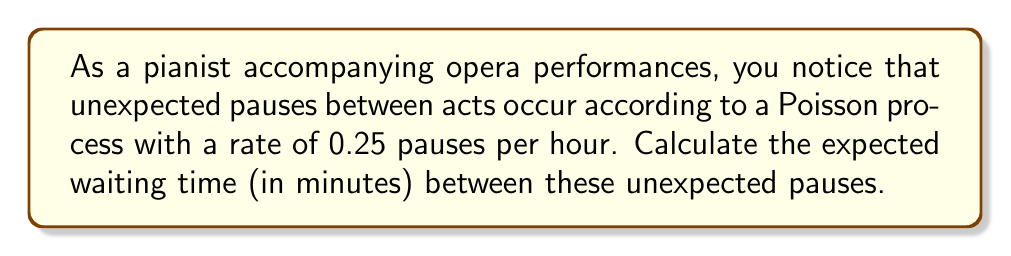Give your solution to this math problem. To solve this problem, we'll follow these steps:

1) In a Poisson process, the time between events follows an exponential distribution. The parameter of this distribution, often denoted as $\lambda$, is the rate at which events occur.

2) Given:
   $\lambda = 0.25$ pauses per hour

3) The expected value (mean) of an exponential distribution is given by:

   $E[X] = \frac{1}{\lambda}$

4) Substituting our value:

   $E[X] = \frac{1}{0.25} = 4$ hours

5) However, we need the answer in minutes. So we convert:

   $4 \text{ hours} \times 60 \text{ minutes/hour} = 240$ minutes

Therefore, the expected waiting time between unexpected pauses is 240 minutes.
Answer: 240 minutes 